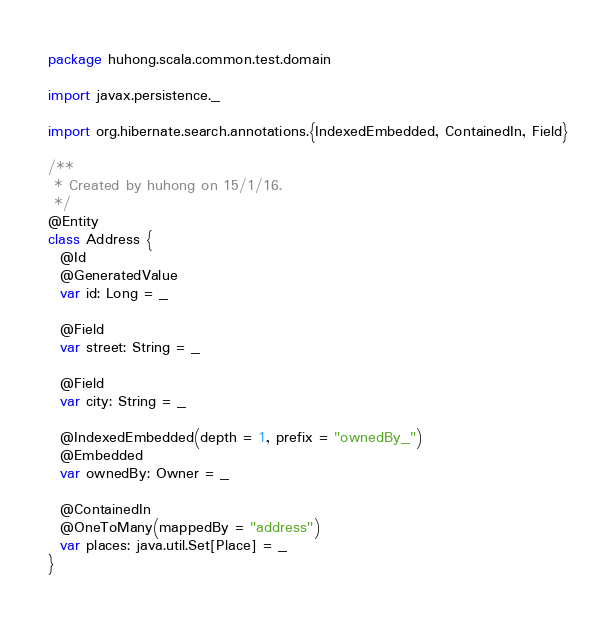Convert code to text. <code><loc_0><loc_0><loc_500><loc_500><_Scala_>package huhong.scala.common.test.domain

import javax.persistence._

import org.hibernate.search.annotations.{IndexedEmbedded, ContainedIn, Field}

/**
 * Created by huhong on 15/1/16.
 */
@Entity
class Address {
  @Id
  @GeneratedValue
  var id: Long = _

  @Field
  var street: String = _

  @Field
  var city: String = _

  @IndexedEmbedded(depth = 1, prefix = "ownedBy_")
  @Embedded
  var ownedBy: Owner = _

  @ContainedIn
  @OneToMany(mappedBy = "address")
  var places: java.util.Set[Place] = _
}
</code> 